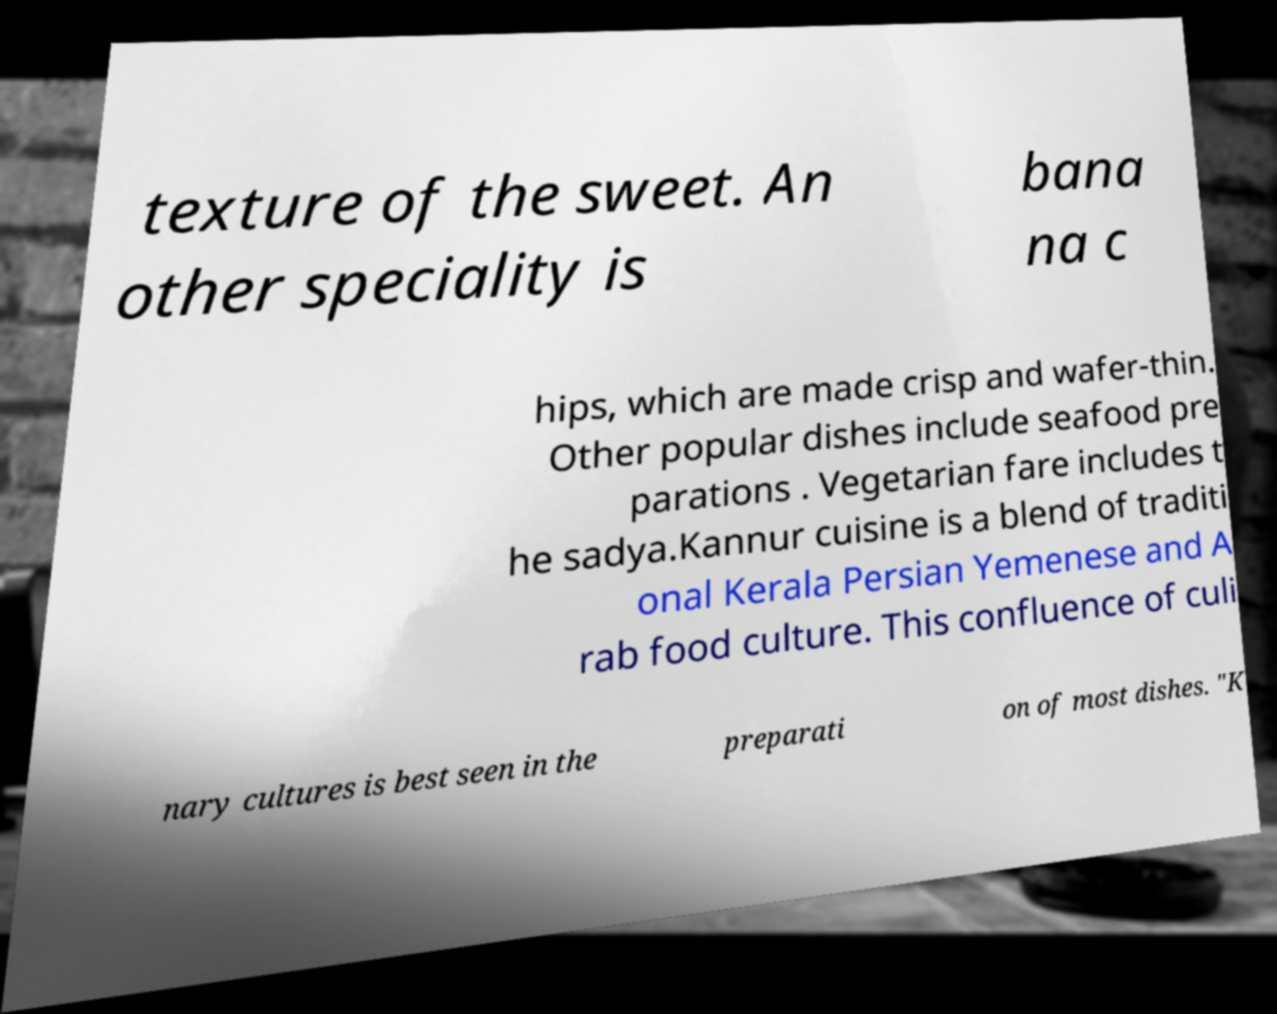I need the written content from this picture converted into text. Can you do that? texture of the sweet. An other speciality is bana na c hips, which are made crisp and wafer-thin. Other popular dishes include seafood pre parations . Vegetarian fare includes t he sadya.Kannur cuisine is a blend of traditi onal Kerala Persian Yemenese and A rab food culture. This confluence of culi nary cultures is best seen in the preparati on of most dishes. "K 